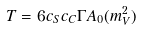<formula> <loc_0><loc_0><loc_500><loc_500>T = 6 c _ { S } c _ { C } \Gamma A _ { 0 } ( m _ { V } ^ { 2 } )</formula> 